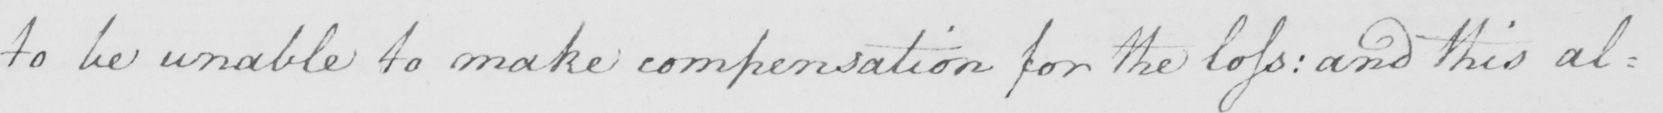Please transcribe the handwritten text in this image. to be unable to make conpensation for the loss :  and this al : 